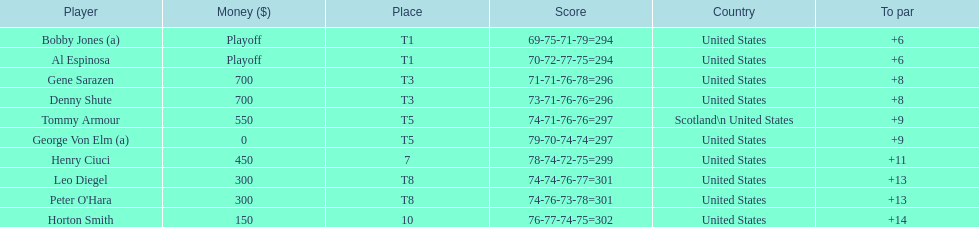Who was the last player in the top 10? Horton Smith. 